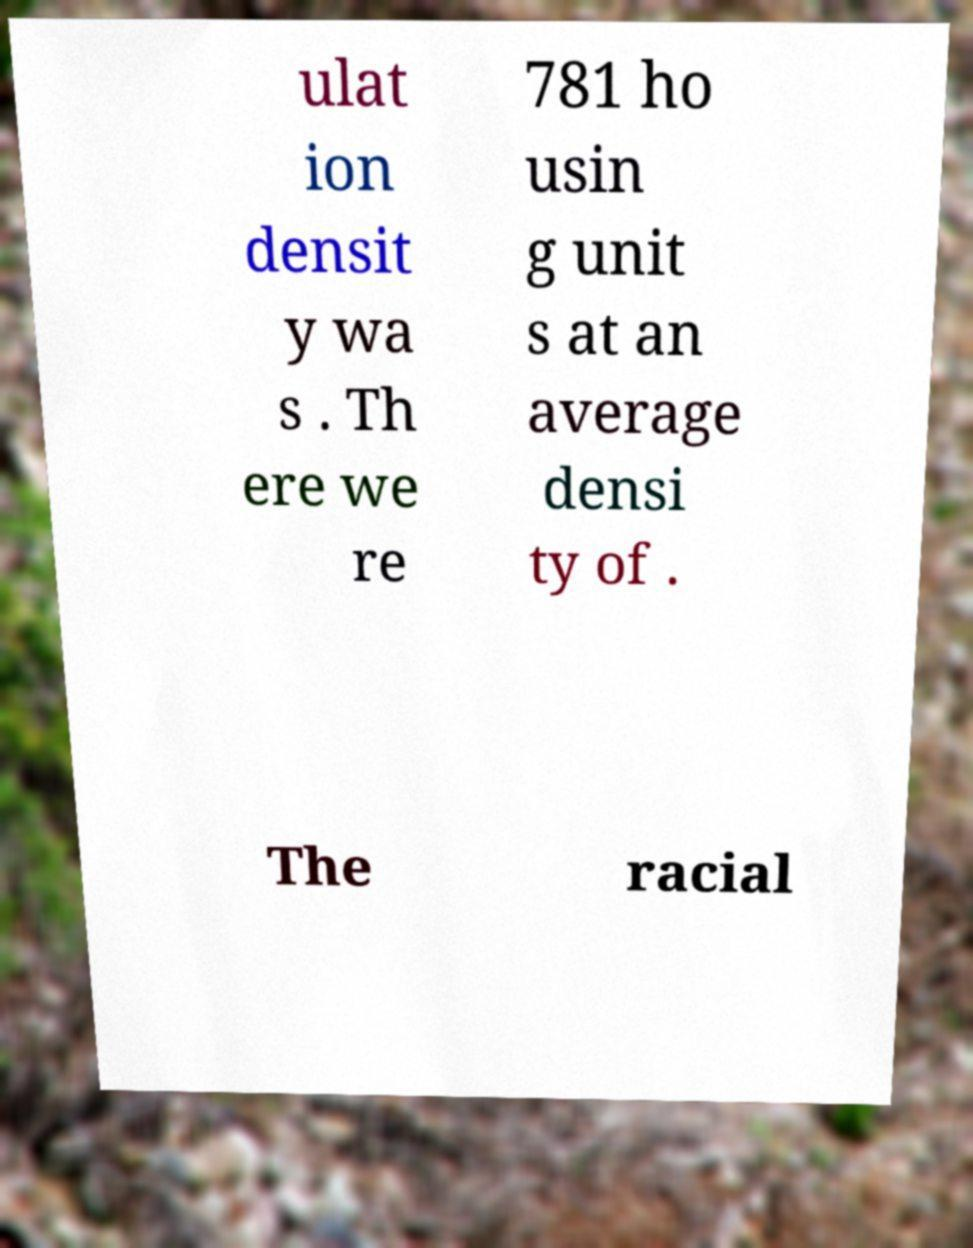There's text embedded in this image that I need extracted. Can you transcribe it verbatim? ulat ion densit y wa s . Th ere we re 781 ho usin g unit s at an average densi ty of . The racial 